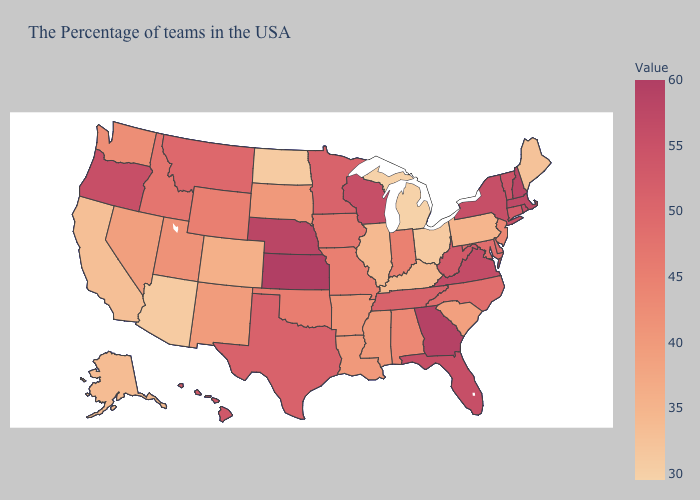Which states have the lowest value in the USA?
Concise answer only. Michigan. Which states have the highest value in the USA?
Write a very short answer. Kansas. Does New Jersey have the lowest value in the Northeast?
Give a very brief answer. No. Does Texas have the lowest value in the USA?
Be succinct. No. 